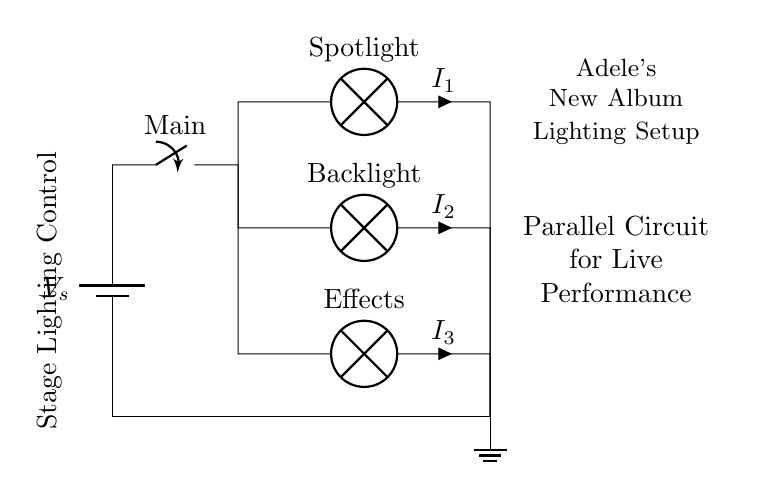What is the main power source in the circuit? The main power source is indicated as a battery labeled V_s.
Answer: battery What type of circuit is used for the stage lighting? The circuit is structured with parallel branches allowing multiple paths for current to flow to different lights.
Answer: parallel What are the three types of lights shown in the circuit? The diagram includes Spotlight, Backlight, and Effects lamps as the types of stage lights.
Answer: Spotlight, Backlight, Effects What is the purpose of the main switch in the circuit? The main switch controls the overall flow of electricity through the parallel circuit to turn all lighting on or off together.
Answer: to control lighting How many branches does the parallel circuit have? The circuit has three branches, each supplying a different type of lamp with its own current.
Answer: three If the current in the spotlight is one amp, what can be said about the current in the other lamps? Since this is a parallel circuit, each branch operates independently, so the current in the other lamps could vary independently of the spotlight.
Answer: varies independently 